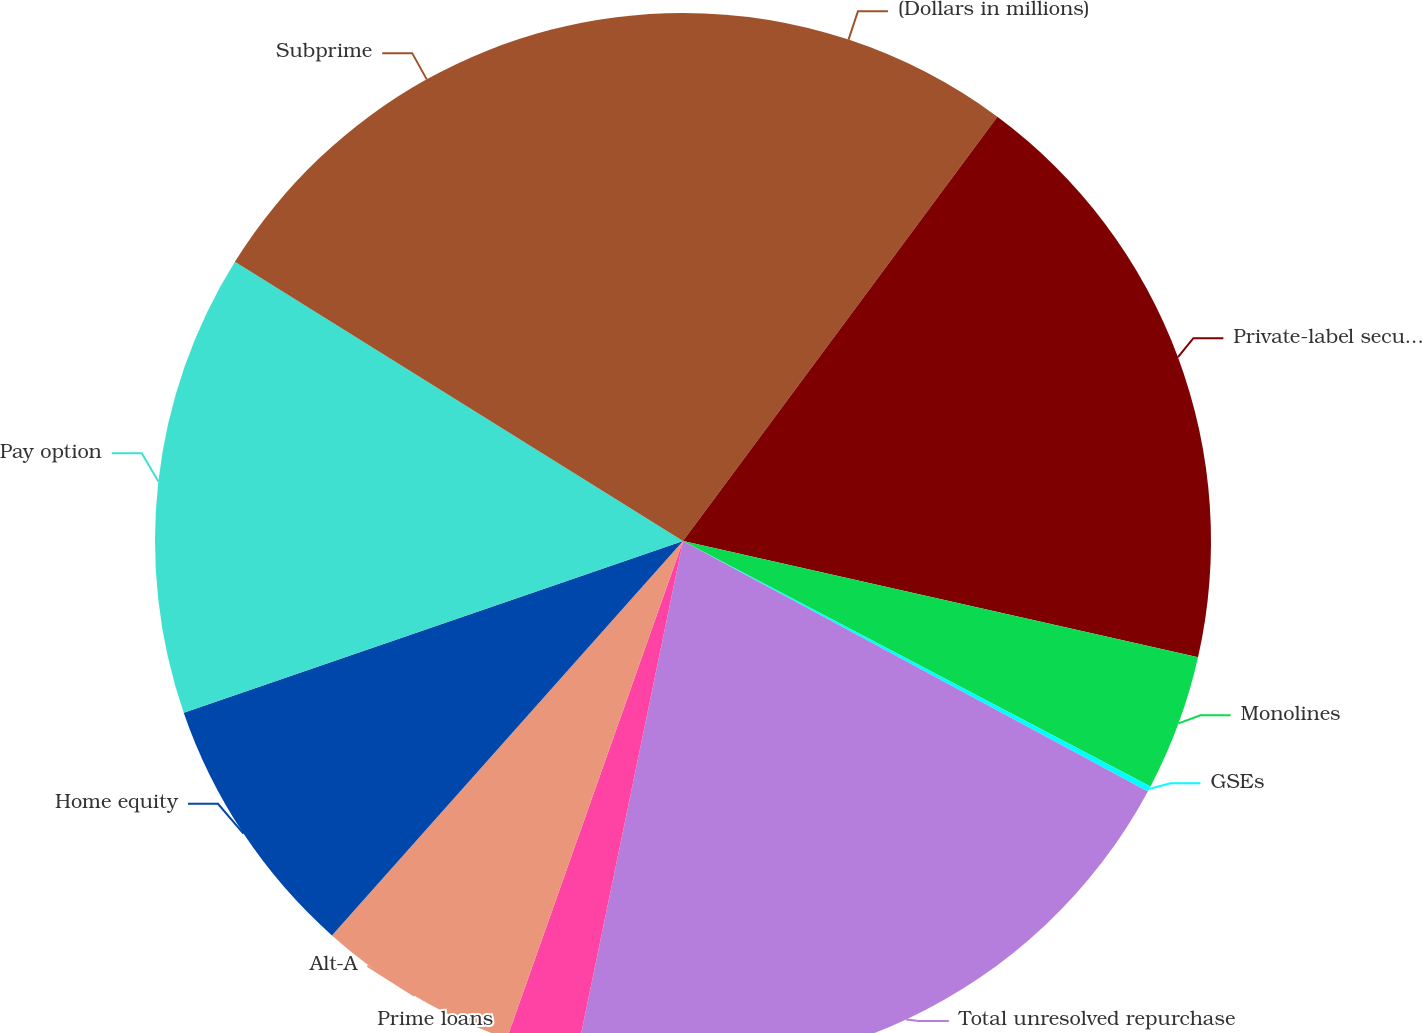Convert chart. <chart><loc_0><loc_0><loc_500><loc_500><pie_chart><fcel>(Dollars in millions)<fcel>Private-label securitization<fcel>Monolines<fcel>GSEs<fcel>Total unresolved repurchase<fcel>Prime loans<fcel>Alt-A<fcel>Home equity<fcel>Pay option<fcel>Subprime<nl><fcel>10.15%<fcel>18.38%<fcel>4.16%<fcel>0.17%<fcel>20.38%<fcel>2.17%<fcel>6.16%<fcel>8.15%<fcel>14.14%<fcel>16.13%<nl></chart> 